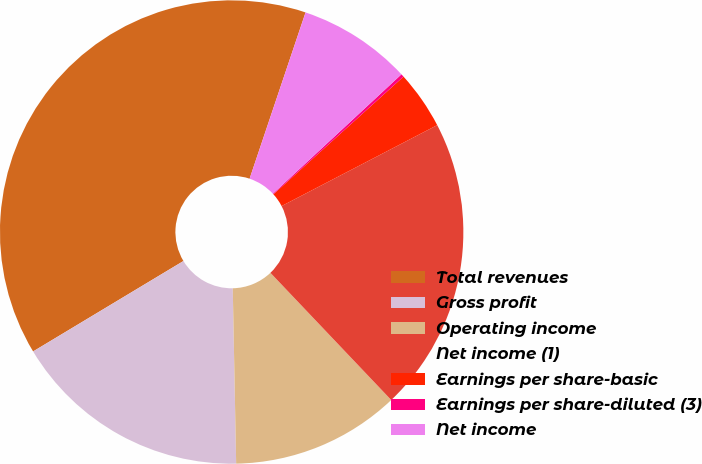<chart> <loc_0><loc_0><loc_500><loc_500><pie_chart><fcel>Total revenues<fcel>Gross profit<fcel>Operating income<fcel>Net income (1)<fcel>Earnings per share-basic<fcel>Earnings per share-diluted (3)<fcel>Net income<nl><fcel>38.78%<fcel>16.69%<fcel>11.78%<fcel>20.54%<fcel>4.07%<fcel>0.21%<fcel>7.92%<nl></chart> 